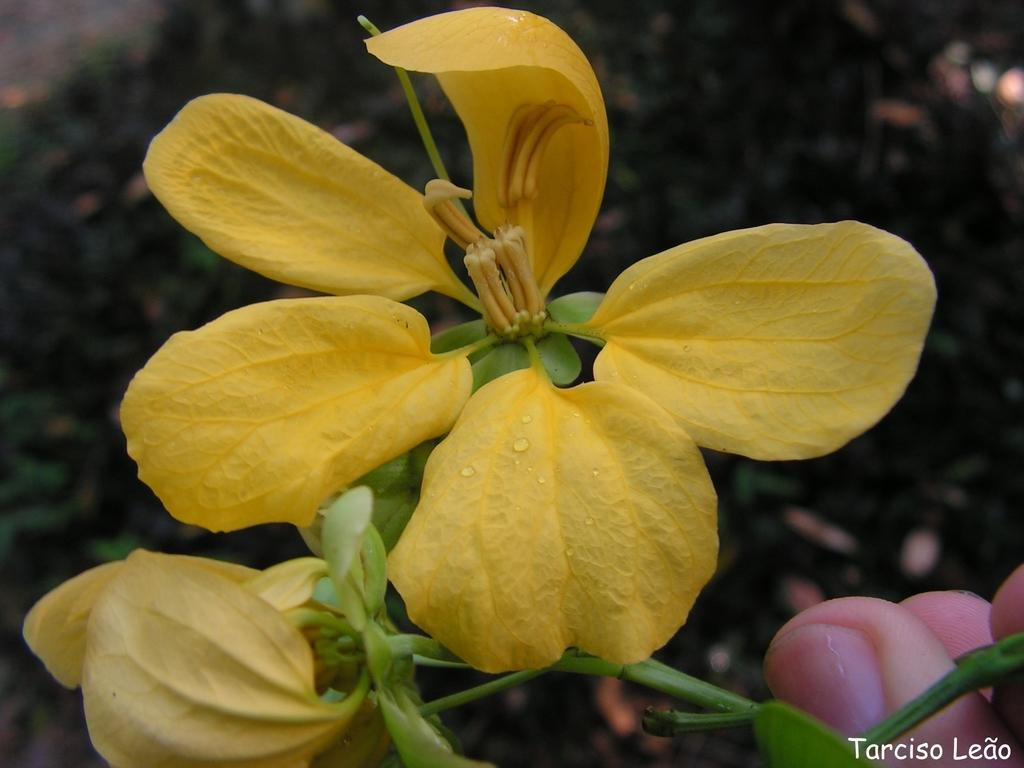What is the main subject of the image? There is a person in the image. What is the person holding in the image? The person is holding a yellow flower. Can you describe the background of the image? The background of the image is blurred. Can you see any ocean waves in the background of the image? There is no ocean or waves visible in the image; the background is blurred. 